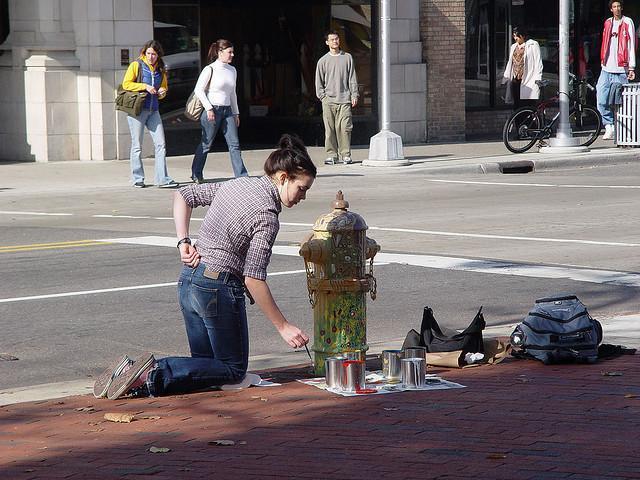How many people are there?
Give a very brief answer. 6. How many cakes are there?
Give a very brief answer. 0. 